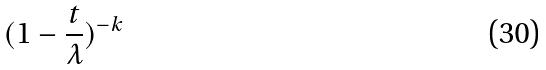Convert formula to latex. <formula><loc_0><loc_0><loc_500><loc_500>( 1 - \frac { t } { \lambda } ) ^ { - k }</formula> 